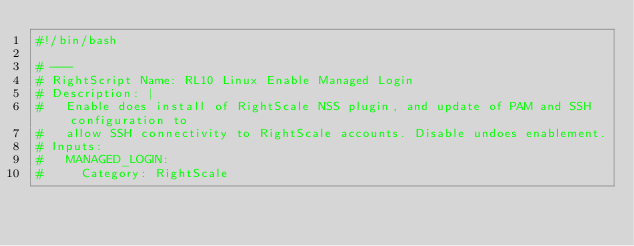<code> <loc_0><loc_0><loc_500><loc_500><_Bash_>#!/bin/bash

# ---
# RightScript Name: RL10 Linux Enable Managed Login
# Description: |
#   Enable does install of RightScale NSS plugin, and update of PAM and SSH configuration to
#   allow SSH connectivity to RightScale accounts. Disable undoes enablement.
# Inputs:
#   MANAGED_LOGIN:
#     Category: RightScale</code> 